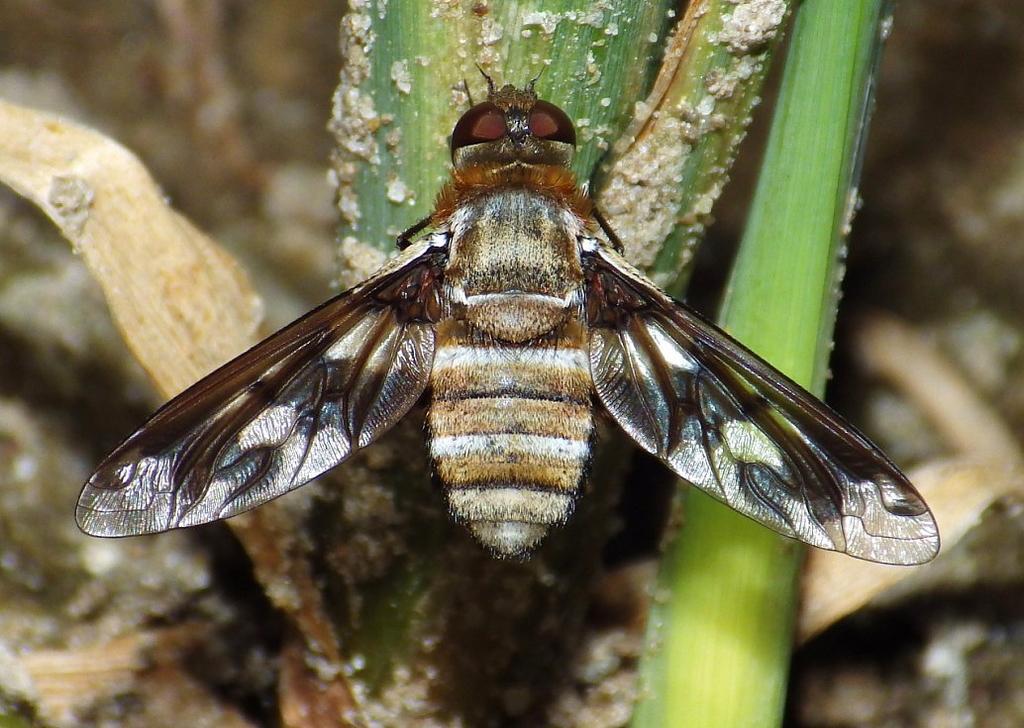Please provide a concise description of this image. This image is taken outdoors. At the bottom of the image there is a ground. In the middle of the image there is a plant and there is a fly on the plant. 